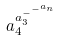Convert formula to latex. <formula><loc_0><loc_0><loc_500><loc_500>a _ { 4 } ^ { a _ { 3 } ^ { - ^ { - ^ { a _ { n } } } } }</formula> 